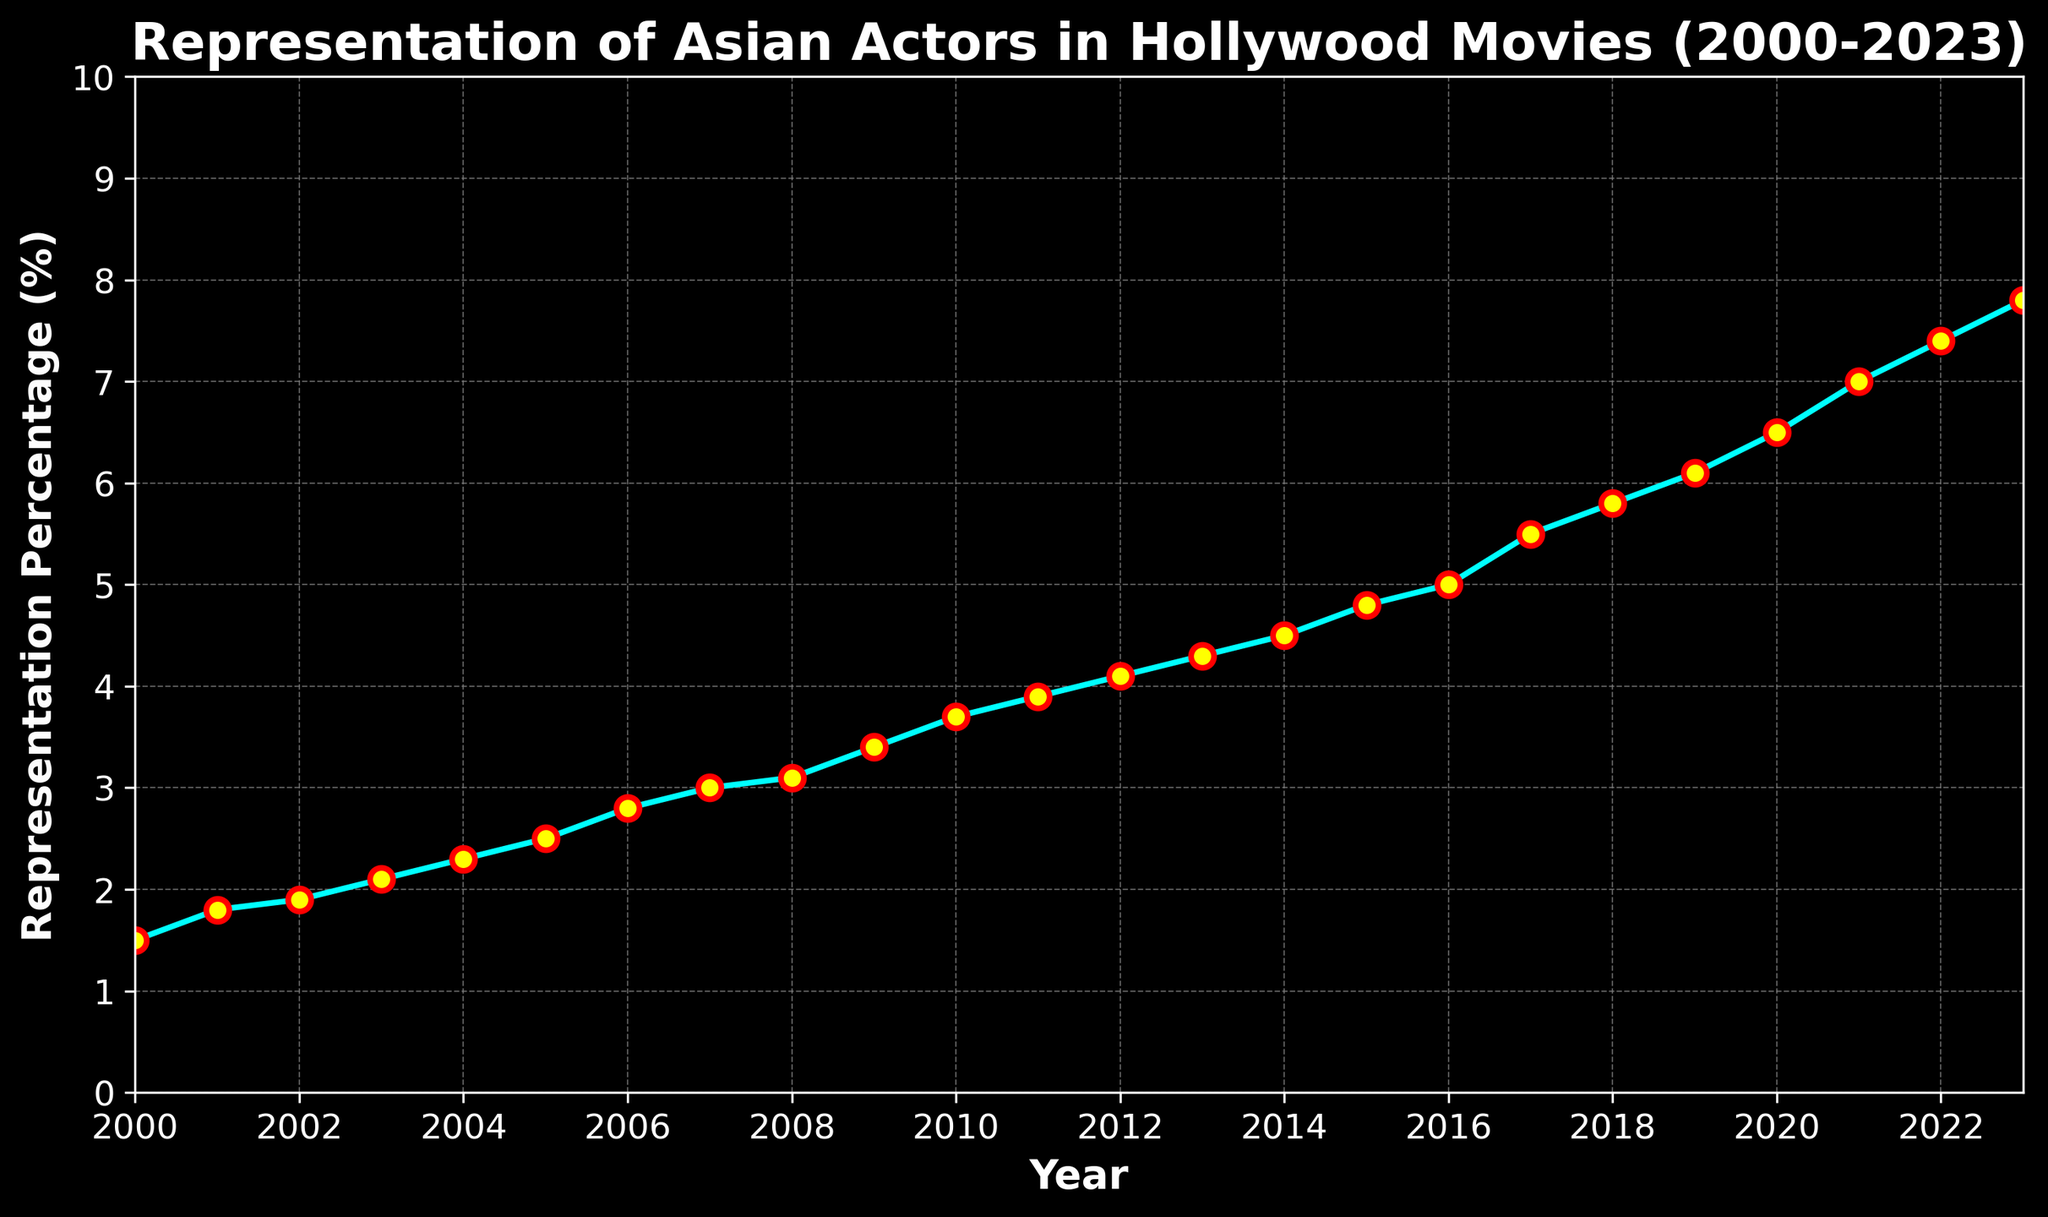What is the percentage representation of Asian actors in Hollywood movies in 2023? Look at the data point corresponding to the year 2023 on the x-axis and check the y-axis value.
Answer: 7.8% How much did the representation percentage increase from 2000 to 2023? Subtract the percentage value of 2000 from the percentage value of 2023: 7.8 - 1.5 = 6.3
Answer: 6.3% Between which two consecutive years did the representation of Asian actors increase the most? Examine the differences between the consecutive data points on the line chart, and identify the years with the largest increase. The most significant increase is between 2020 (6.5%) and 2021 (7.0%), so 2021 - 2020 = 0.5, which is the largest single-year increase.
Answer: 2020 and 2021 In which year did the representation percentage first exceed 5%? Trace the line chart until the y-axis value first crosses the 5% mark, which happens between 2016 and 2017. Hence, the first year it exceeds 5% is 2017.
Answer: 2017 What is the average representation percentage of Asian actors from 2000 to 2010? To find the average, sum the values from 2000 to 2010 and divide by the number of years: (1.5 + 1.8 + 1.9 + 2.1 + 2.3 + 2.5 + 2.8 + 3.0 + 3.1 + 3.4 + 3.7) / 11 = 2.7273
Answer: 2.73 How does the representation percentage change from 2005 to 2010 visually appear? The line chart shows that the percentage steadily increases from 2.5% in 2005 to 3.7% in 2010, indicating a positive trend.
Answer: Steady increase What is the overall trend in the representation of Asian actors from 2000 to 2023? Observing the overall line chart, the representation percentage continuously increases over the years, indicating a rising trend.
Answer: Rising trend What was the rate of increase in representation from 2018 to 2022? Calculate the rate as the difference in percentage over the number of years: (7.4 - 5.8) / (2022 - 2018) = 1.6 / 4 = 0.4% per year
Answer: 0.4% per year Which color marker represents the data points, and what's the marker outline color? The markers on the data points are a combination of yellow for the marker fill and red for the marker outline.
Answer: Yellow with a red outline Is there any year where the representation percentage remained the same as the previous year? Scan the line chart for consecutive data points that are the same. Each year from 2000 to 2023 shows an increase in the representation percentage; thus, there are no years with the same percentage as the previous year.
Answer: No 